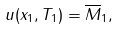Convert formula to latex. <formula><loc_0><loc_0><loc_500><loc_500>u ( x _ { 1 } , T _ { 1 } ) = \overline { M } _ { 1 } ,</formula> 